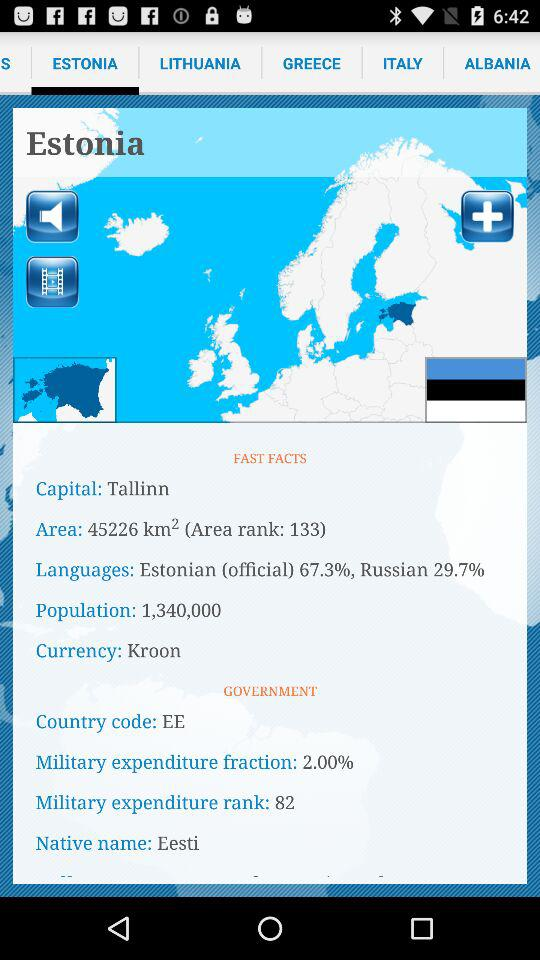What's the currency? The currency is Kroon. 